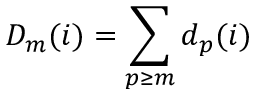<formula> <loc_0><loc_0><loc_500><loc_500>D _ { m } ( i ) = \sum _ { p \geq m } d _ { p } ( i )</formula> 